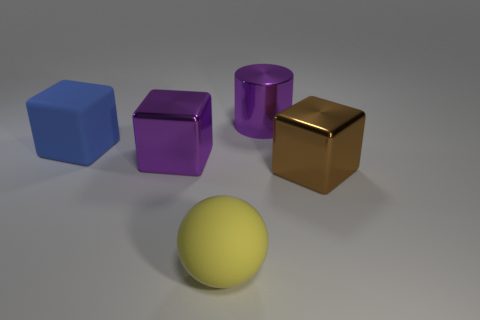What number of purple cubes are the same size as the blue matte block?
Offer a very short reply. 1. There is a blue object that is the same shape as the brown thing; what is its material?
Your answer should be very brief. Rubber. What is the shape of the object that is both in front of the purple cube and behind the matte ball?
Offer a terse response. Cube. There is a thing that is behind the big blue block; what shape is it?
Give a very brief answer. Cylinder. What number of things are in front of the blue thing and to the left of the large matte ball?
Make the answer very short. 1. There is a blue object; is its size the same as the metal cube that is left of the yellow ball?
Provide a succinct answer. Yes. There is a metallic cube that is to the left of the shiny block in front of the big metallic block behind the large brown shiny thing; what is its size?
Give a very brief answer. Large. What size is the metal block that is to the right of the cylinder?
Your answer should be very brief. Large. There is a large object that is made of the same material as the yellow ball; what is its shape?
Offer a terse response. Cube. Are the purple object that is left of the yellow thing and the sphere made of the same material?
Your answer should be very brief. No. 